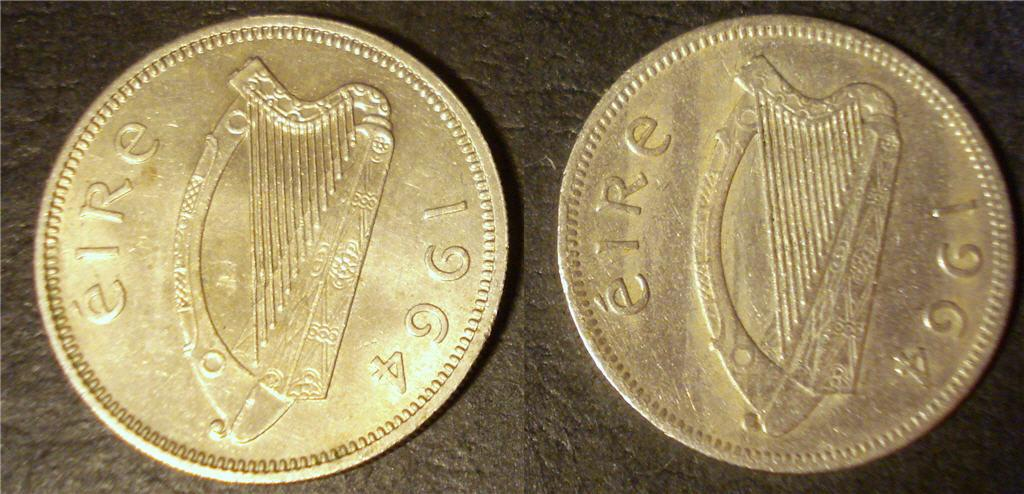<image>
Create a compact narrative representing the image presented. two bronze coins with words EIRE 1964 and a harp design 